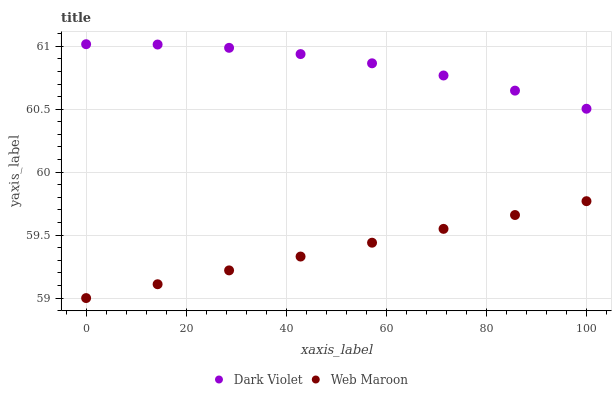Does Web Maroon have the minimum area under the curve?
Answer yes or no. Yes. Does Dark Violet have the maximum area under the curve?
Answer yes or no. Yes. Does Dark Violet have the minimum area under the curve?
Answer yes or no. No. Is Web Maroon the smoothest?
Answer yes or no. Yes. Is Dark Violet the roughest?
Answer yes or no. Yes. Is Dark Violet the smoothest?
Answer yes or no. No. Does Web Maroon have the lowest value?
Answer yes or no. Yes. Does Dark Violet have the lowest value?
Answer yes or no. No. Does Dark Violet have the highest value?
Answer yes or no. Yes. Is Web Maroon less than Dark Violet?
Answer yes or no. Yes. Is Dark Violet greater than Web Maroon?
Answer yes or no. Yes. Does Web Maroon intersect Dark Violet?
Answer yes or no. No. 